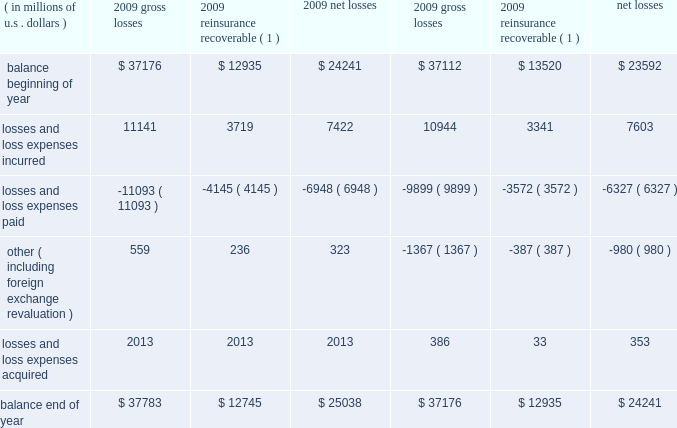Critical accounting estimates our consolidated financial statements include amounts that , either by their nature or due to requirements of accounting princi- ples generally accepted in the u.s .
( gaap ) , are determined using best estimates and assumptions .
While we believe that the amounts included in our consolidated financial statements reflect our best judgment , actual amounts could ultimately materi- ally differ from those currently presented .
We believe the items that require the most subjective and complex estimates are : 2022 unpaid loss and loss expense reserves , including long-tail asbestos and environmental ( a&e ) reserves ; 2022 future policy benefits reserves ; 2022 valuation of value of business acquired ( voba ) and amortization of deferred policy acquisition costs and voba ; 2022 the assessment of risk transfer for certain structured insurance and reinsurance contracts ; 2022 reinsurance recoverable , including a provision for uncollectible reinsurance ; 2022 the valuation of our investment portfolio and assessment of other-than-temporary impairments ( otti ) ; 2022 the valuation of deferred tax assets ; 2022 the valuation of derivative instruments related to guaranteed minimum income benefits ( gmib ) ; and 2022 the valuation of goodwill .
We believe our accounting policies for these items are of critical importance to our consolidated financial statements .
The following discussion provides more information regarding the estimates and assumptions required to arrive at these amounts and should be read in conjunction with the sections entitled : prior period development , asbestos and environmental and other run-off liabilities , reinsurance recoverable on ceded reinsurance , investments , net realized gains ( losses ) , and other income and expense items .
Unpaid losses and loss expenses overview and key data as an insurance and reinsurance company , we are required , by applicable laws and regulations and gaap , to establish loss and loss expense reserves for the estimated unpaid portion of the ultimate liability for losses and loss expenses under the terms of our policies and agreements with our insured and reinsured customers .
The estimate of the liabilities includes provisions for claims that have been reported but are unpaid at the balance sheet date ( case reserves ) and for future obligations on claims that have been incurred but not reported ( ibnr ) at the balance sheet date ( ibnr may also include a provision for additional development on reported claims in instances where the case reserve is viewed to be potentially insufficient ) .
Loss reserves also include an estimate of expenses associated with processing and settling unpaid claims ( loss expenses ) .
At december 31 , 2009 , our gross unpaid loss and loss expense reserves were $ 37.8 billion and our net unpaid loss and loss expense reserves were $ 25 billion .
With the exception of certain structured settlements , for which the timing and amount of future claim pay- ments are reliably determinable , our loss reserves are not discounted for the time value of money .
In connection with such structured settlements , we carry net reserves of $ 76 million , net of discount .
The table below presents a roll-forward of our unpaid losses and loss expenses for the years ended december 31 , 2009 and 2008. .
( 1 ) net of provision for uncollectible reinsurance .
What was the percent of the losses in 2009 based on the unpaid loss and loss expense reserves? 
Computations: (37.8 - 25)
Answer: 12.8. 